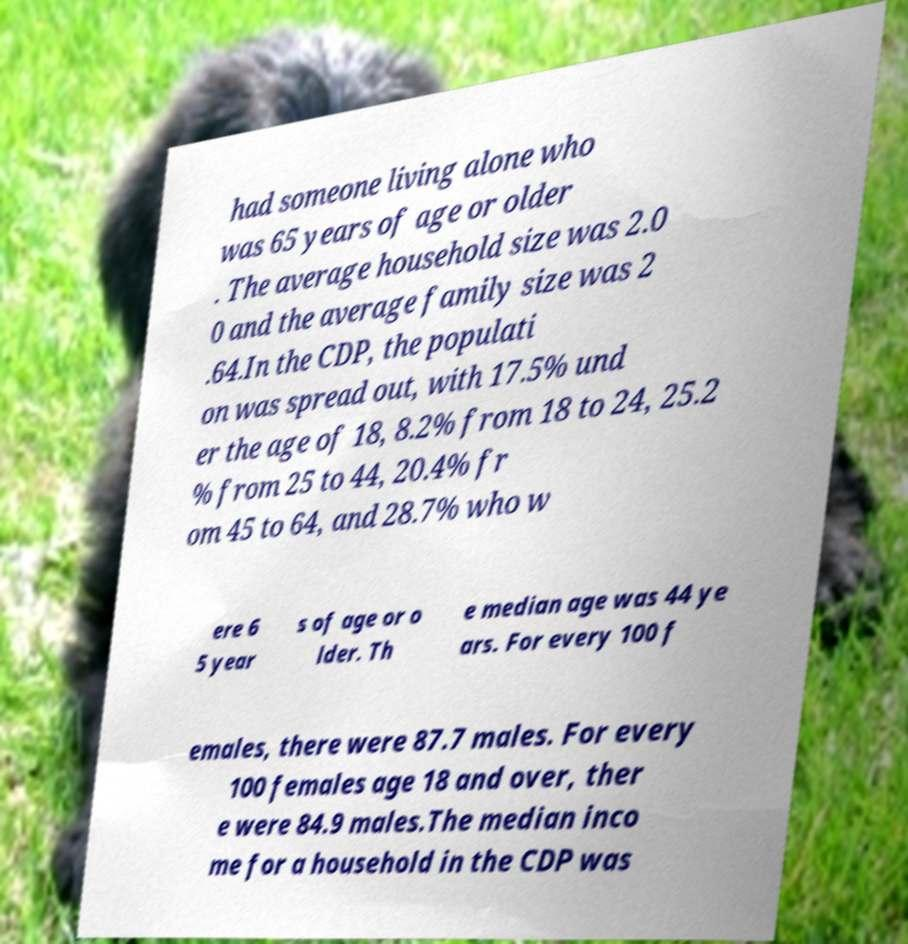For documentation purposes, I need the text within this image transcribed. Could you provide that? had someone living alone who was 65 years of age or older . The average household size was 2.0 0 and the average family size was 2 .64.In the CDP, the populati on was spread out, with 17.5% und er the age of 18, 8.2% from 18 to 24, 25.2 % from 25 to 44, 20.4% fr om 45 to 64, and 28.7% who w ere 6 5 year s of age or o lder. Th e median age was 44 ye ars. For every 100 f emales, there were 87.7 males. For every 100 females age 18 and over, ther e were 84.9 males.The median inco me for a household in the CDP was 